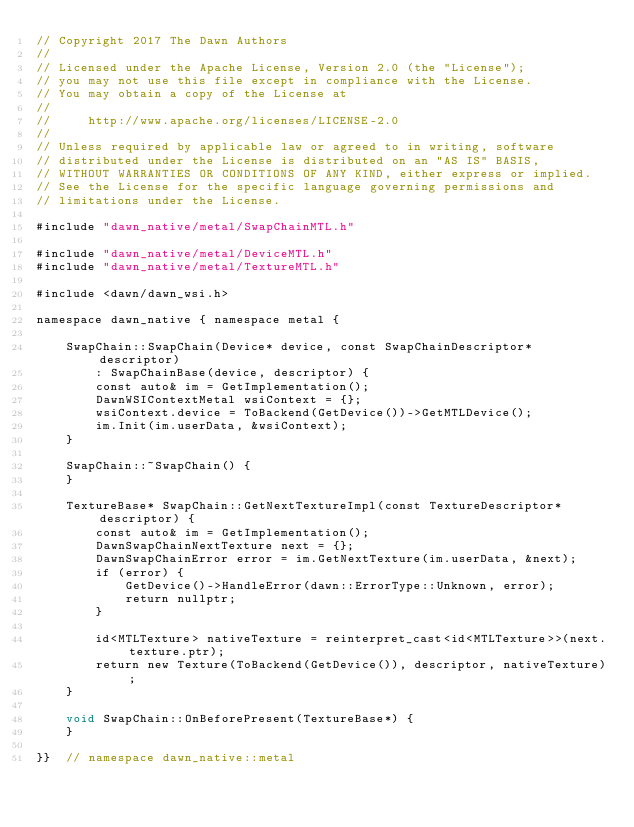<code> <loc_0><loc_0><loc_500><loc_500><_ObjectiveC_>// Copyright 2017 The Dawn Authors
//
// Licensed under the Apache License, Version 2.0 (the "License");
// you may not use this file except in compliance with the License.
// You may obtain a copy of the License at
//
//     http://www.apache.org/licenses/LICENSE-2.0
//
// Unless required by applicable law or agreed to in writing, software
// distributed under the License is distributed on an "AS IS" BASIS,
// WITHOUT WARRANTIES OR CONDITIONS OF ANY KIND, either express or implied.
// See the License for the specific language governing permissions and
// limitations under the License.

#include "dawn_native/metal/SwapChainMTL.h"

#include "dawn_native/metal/DeviceMTL.h"
#include "dawn_native/metal/TextureMTL.h"

#include <dawn/dawn_wsi.h>

namespace dawn_native { namespace metal {

    SwapChain::SwapChain(Device* device, const SwapChainDescriptor* descriptor)
        : SwapChainBase(device, descriptor) {
        const auto& im = GetImplementation();
        DawnWSIContextMetal wsiContext = {};
        wsiContext.device = ToBackend(GetDevice())->GetMTLDevice();
        im.Init(im.userData, &wsiContext);
    }

    SwapChain::~SwapChain() {
    }

    TextureBase* SwapChain::GetNextTextureImpl(const TextureDescriptor* descriptor) {
        const auto& im = GetImplementation();
        DawnSwapChainNextTexture next = {};
        DawnSwapChainError error = im.GetNextTexture(im.userData, &next);
        if (error) {
            GetDevice()->HandleError(dawn::ErrorType::Unknown, error);
            return nullptr;
        }

        id<MTLTexture> nativeTexture = reinterpret_cast<id<MTLTexture>>(next.texture.ptr);
        return new Texture(ToBackend(GetDevice()), descriptor, nativeTexture);
    }

    void SwapChain::OnBeforePresent(TextureBase*) {
    }

}}  // namespace dawn_native::metal
</code> 